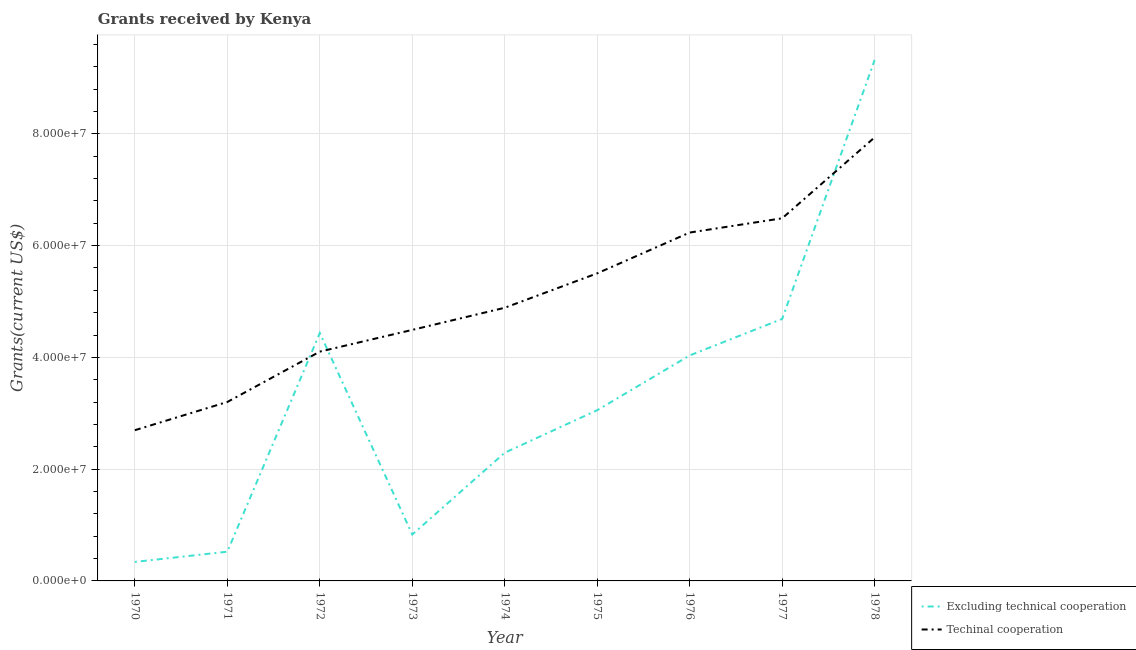Does the line corresponding to amount of grants received(including technical cooperation) intersect with the line corresponding to amount of grants received(excluding technical cooperation)?
Ensure brevity in your answer.  Yes. Is the number of lines equal to the number of legend labels?
Your answer should be compact. Yes. What is the amount of grants received(including technical cooperation) in 1973?
Your answer should be very brief. 4.49e+07. Across all years, what is the maximum amount of grants received(excluding technical cooperation)?
Your answer should be compact. 9.32e+07. Across all years, what is the minimum amount of grants received(including technical cooperation)?
Provide a succinct answer. 2.70e+07. In which year was the amount of grants received(excluding technical cooperation) maximum?
Keep it short and to the point. 1978. In which year was the amount of grants received(excluding technical cooperation) minimum?
Your answer should be compact. 1970. What is the total amount of grants received(excluding technical cooperation) in the graph?
Give a very brief answer. 2.95e+08. What is the difference between the amount of grants received(excluding technical cooperation) in 1974 and that in 1976?
Offer a terse response. -1.74e+07. What is the difference between the amount of grants received(including technical cooperation) in 1970 and the amount of grants received(excluding technical cooperation) in 1976?
Make the answer very short. -1.34e+07. What is the average amount of grants received(excluding technical cooperation) per year?
Your answer should be compact. 3.28e+07. In the year 1972, what is the difference between the amount of grants received(excluding technical cooperation) and amount of grants received(including technical cooperation)?
Your answer should be very brief. 3.33e+06. What is the ratio of the amount of grants received(excluding technical cooperation) in 1972 to that in 1976?
Your answer should be compact. 1.1. Is the difference between the amount of grants received(including technical cooperation) in 1971 and 1974 greater than the difference between the amount of grants received(excluding technical cooperation) in 1971 and 1974?
Your response must be concise. Yes. What is the difference between the highest and the second highest amount of grants received(excluding technical cooperation)?
Your response must be concise. 4.63e+07. What is the difference between the highest and the lowest amount of grants received(including technical cooperation)?
Provide a succinct answer. 5.24e+07. Does the amount of grants received(excluding technical cooperation) monotonically increase over the years?
Offer a terse response. No. Is the amount of grants received(excluding technical cooperation) strictly greater than the amount of grants received(including technical cooperation) over the years?
Your response must be concise. No. Is the amount of grants received(excluding technical cooperation) strictly less than the amount of grants received(including technical cooperation) over the years?
Provide a succinct answer. No. How many lines are there?
Make the answer very short. 2. How many years are there in the graph?
Keep it short and to the point. 9. Does the graph contain any zero values?
Your response must be concise. No. Where does the legend appear in the graph?
Your response must be concise. Bottom right. What is the title of the graph?
Provide a succinct answer. Grants received by Kenya. Does "Resident" appear as one of the legend labels in the graph?
Keep it short and to the point. No. What is the label or title of the X-axis?
Offer a terse response. Year. What is the label or title of the Y-axis?
Provide a succinct answer. Grants(current US$). What is the Grants(current US$) in Excluding technical cooperation in 1970?
Your answer should be compact. 3.40e+06. What is the Grants(current US$) in Techinal cooperation in 1970?
Your response must be concise. 2.70e+07. What is the Grants(current US$) of Excluding technical cooperation in 1971?
Your answer should be very brief. 5.23e+06. What is the Grants(current US$) in Techinal cooperation in 1971?
Your answer should be compact. 3.20e+07. What is the Grants(current US$) in Excluding technical cooperation in 1972?
Keep it short and to the point. 4.44e+07. What is the Grants(current US$) in Techinal cooperation in 1972?
Your answer should be compact. 4.10e+07. What is the Grants(current US$) in Excluding technical cooperation in 1973?
Make the answer very short. 8.30e+06. What is the Grants(current US$) of Techinal cooperation in 1973?
Provide a short and direct response. 4.49e+07. What is the Grants(current US$) in Excluding technical cooperation in 1974?
Provide a succinct answer. 2.29e+07. What is the Grants(current US$) in Techinal cooperation in 1974?
Provide a succinct answer. 4.89e+07. What is the Grants(current US$) in Excluding technical cooperation in 1975?
Give a very brief answer. 3.06e+07. What is the Grants(current US$) of Techinal cooperation in 1975?
Give a very brief answer. 5.50e+07. What is the Grants(current US$) of Excluding technical cooperation in 1976?
Your answer should be compact. 4.04e+07. What is the Grants(current US$) in Techinal cooperation in 1976?
Make the answer very short. 6.23e+07. What is the Grants(current US$) in Excluding technical cooperation in 1977?
Offer a terse response. 4.69e+07. What is the Grants(current US$) of Techinal cooperation in 1977?
Give a very brief answer. 6.49e+07. What is the Grants(current US$) in Excluding technical cooperation in 1978?
Provide a short and direct response. 9.32e+07. What is the Grants(current US$) in Techinal cooperation in 1978?
Your answer should be very brief. 7.94e+07. Across all years, what is the maximum Grants(current US$) of Excluding technical cooperation?
Your response must be concise. 9.32e+07. Across all years, what is the maximum Grants(current US$) in Techinal cooperation?
Offer a very short reply. 7.94e+07. Across all years, what is the minimum Grants(current US$) of Excluding technical cooperation?
Your answer should be compact. 3.40e+06. Across all years, what is the minimum Grants(current US$) of Techinal cooperation?
Your answer should be very brief. 2.70e+07. What is the total Grants(current US$) of Excluding technical cooperation in the graph?
Provide a succinct answer. 2.95e+08. What is the total Grants(current US$) in Techinal cooperation in the graph?
Offer a terse response. 4.55e+08. What is the difference between the Grants(current US$) in Excluding technical cooperation in 1970 and that in 1971?
Your answer should be compact. -1.83e+06. What is the difference between the Grants(current US$) of Techinal cooperation in 1970 and that in 1971?
Offer a very short reply. -5.05e+06. What is the difference between the Grants(current US$) in Excluding technical cooperation in 1970 and that in 1972?
Offer a terse response. -4.10e+07. What is the difference between the Grants(current US$) of Techinal cooperation in 1970 and that in 1972?
Offer a terse response. -1.41e+07. What is the difference between the Grants(current US$) in Excluding technical cooperation in 1970 and that in 1973?
Provide a succinct answer. -4.90e+06. What is the difference between the Grants(current US$) of Techinal cooperation in 1970 and that in 1973?
Provide a succinct answer. -1.80e+07. What is the difference between the Grants(current US$) in Excluding technical cooperation in 1970 and that in 1974?
Your answer should be compact. -1.95e+07. What is the difference between the Grants(current US$) in Techinal cooperation in 1970 and that in 1974?
Ensure brevity in your answer.  -2.19e+07. What is the difference between the Grants(current US$) in Excluding technical cooperation in 1970 and that in 1975?
Make the answer very short. -2.72e+07. What is the difference between the Grants(current US$) in Techinal cooperation in 1970 and that in 1975?
Provide a succinct answer. -2.81e+07. What is the difference between the Grants(current US$) in Excluding technical cooperation in 1970 and that in 1976?
Your answer should be very brief. -3.70e+07. What is the difference between the Grants(current US$) of Techinal cooperation in 1970 and that in 1976?
Provide a succinct answer. -3.54e+07. What is the difference between the Grants(current US$) of Excluding technical cooperation in 1970 and that in 1977?
Your response must be concise. -4.35e+07. What is the difference between the Grants(current US$) of Techinal cooperation in 1970 and that in 1977?
Your response must be concise. -3.79e+07. What is the difference between the Grants(current US$) of Excluding technical cooperation in 1970 and that in 1978?
Offer a terse response. -8.98e+07. What is the difference between the Grants(current US$) in Techinal cooperation in 1970 and that in 1978?
Make the answer very short. -5.24e+07. What is the difference between the Grants(current US$) of Excluding technical cooperation in 1971 and that in 1972?
Your response must be concise. -3.91e+07. What is the difference between the Grants(current US$) in Techinal cooperation in 1971 and that in 1972?
Keep it short and to the point. -9.01e+06. What is the difference between the Grants(current US$) in Excluding technical cooperation in 1971 and that in 1973?
Your answer should be very brief. -3.07e+06. What is the difference between the Grants(current US$) in Techinal cooperation in 1971 and that in 1973?
Ensure brevity in your answer.  -1.29e+07. What is the difference between the Grants(current US$) in Excluding technical cooperation in 1971 and that in 1974?
Keep it short and to the point. -1.77e+07. What is the difference between the Grants(current US$) of Techinal cooperation in 1971 and that in 1974?
Your answer should be very brief. -1.69e+07. What is the difference between the Grants(current US$) of Excluding technical cooperation in 1971 and that in 1975?
Keep it short and to the point. -2.53e+07. What is the difference between the Grants(current US$) of Techinal cooperation in 1971 and that in 1975?
Provide a short and direct response. -2.30e+07. What is the difference between the Grants(current US$) in Excluding technical cooperation in 1971 and that in 1976?
Ensure brevity in your answer.  -3.51e+07. What is the difference between the Grants(current US$) in Techinal cooperation in 1971 and that in 1976?
Offer a terse response. -3.03e+07. What is the difference between the Grants(current US$) of Excluding technical cooperation in 1971 and that in 1977?
Ensure brevity in your answer.  -4.16e+07. What is the difference between the Grants(current US$) of Techinal cooperation in 1971 and that in 1977?
Offer a terse response. -3.29e+07. What is the difference between the Grants(current US$) in Excluding technical cooperation in 1971 and that in 1978?
Provide a succinct answer. -8.80e+07. What is the difference between the Grants(current US$) in Techinal cooperation in 1971 and that in 1978?
Your response must be concise. -4.74e+07. What is the difference between the Grants(current US$) in Excluding technical cooperation in 1972 and that in 1973?
Offer a terse response. 3.61e+07. What is the difference between the Grants(current US$) in Techinal cooperation in 1972 and that in 1973?
Offer a terse response. -3.89e+06. What is the difference between the Grants(current US$) of Excluding technical cooperation in 1972 and that in 1974?
Your answer should be compact. 2.14e+07. What is the difference between the Grants(current US$) in Techinal cooperation in 1972 and that in 1974?
Offer a terse response. -7.85e+06. What is the difference between the Grants(current US$) of Excluding technical cooperation in 1972 and that in 1975?
Provide a succinct answer. 1.38e+07. What is the difference between the Grants(current US$) in Techinal cooperation in 1972 and that in 1975?
Keep it short and to the point. -1.40e+07. What is the difference between the Grants(current US$) of Excluding technical cooperation in 1972 and that in 1976?
Your response must be concise. 4.01e+06. What is the difference between the Grants(current US$) in Techinal cooperation in 1972 and that in 1976?
Provide a short and direct response. -2.13e+07. What is the difference between the Grants(current US$) of Excluding technical cooperation in 1972 and that in 1977?
Offer a terse response. -2.52e+06. What is the difference between the Grants(current US$) in Techinal cooperation in 1972 and that in 1977?
Provide a succinct answer. -2.39e+07. What is the difference between the Grants(current US$) in Excluding technical cooperation in 1972 and that in 1978?
Your answer should be compact. -4.89e+07. What is the difference between the Grants(current US$) in Techinal cooperation in 1972 and that in 1978?
Offer a very short reply. -3.83e+07. What is the difference between the Grants(current US$) of Excluding technical cooperation in 1973 and that in 1974?
Your response must be concise. -1.46e+07. What is the difference between the Grants(current US$) in Techinal cooperation in 1973 and that in 1974?
Ensure brevity in your answer.  -3.96e+06. What is the difference between the Grants(current US$) in Excluding technical cooperation in 1973 and that in 1975?
Provide a succinct answer. -2.22e+07. What is the difference between the Grants(current US$) of Techinal cooperation in 1973 and that in 1975?
Your answer should be very brief. -1.01e+07. What is the difference between the Grants(current US$) in Excluding technical cooperation in 1973 and that in 1976?
Provide a short and direct response. -3.20e+07. What is the difference between the Grants(current US$) of Techinal cooperation in 1973 and that in 1976?
Offer a very short reply. -1.74e+07. What is the difference between the Grants(current US$) in Excluding technical cooperation in 1973 and that in 1977?
Give a very brief answer. -3.86e+07. What is the difference between the Grants(current US$) in Techinal cooperation in 1973 and that in 1977?
Your answer should be compact. -2.00e+07. What is the difference between the Grants(current US$) of Excluding technical cooperation in 1973 and that in 1978?
Your answer should be very brief. -8.49e+07. What is the difference between the Grants(current US$) in Techinal cooperation in 1973 and that in 1978?
Provide a short and direct response. -3.44e+07. What is the difference between the Grants(current US$) of Excluding technical cooperation in 1974 and that in 1975?
Offer a terse response. -7.61e+06. What is the difference between the Grants(current US$) in Techinal cooperation in 1974 and that in 1975?
Your answer should be compact. -6.16e+06. What is the difference between the Grants(current US$) of Excluding technical cooperation in 1974 and that in 1976?
Your answer should be very brief. -1.74e+07. What is the difference between the Grants(current US$) of Techinal cooperation in 1974 and that in 1976?
Your answer should be very brief. -1.35e+07. What is the difference between the Grants(current US$) of Excluding technical cooperation in 1974 and that in 1977?
Your response must be concise. -2.39e+07. What is the difference between the Grants(current US$) in Techinal cooperation in 1974 and that in 1977?
Your answer should be compact. -1.60e+07. What is the difference between the Grants(current US$) of Excluding technical cooperation in 1974 and that in 1978?
Your response must be concise. -7.03e+07. What is the difference between the Grants(current US$) in Techinal cooperation in 1974 and that in 1978?
Your answer should be compact. -3.05e+07. What is the difference between the Grants(current US$) of Excluding technical cooperation in 1975 and that in 1976?
Your answer should be very brief. -9.80e+06. What is the difference between the Grants(current US$) of Techinal cooperation in 1975 and that in 1976?
Make the answer very short. -7.30e+06. What is the difference between the Grants(current US$) in Excluding technical cooperation in 1975 and that in 1977?
Provide a short and direct response. -1.63e+07. What is the difference between the Grants(current US$) in Techinal cooperation in 1975 and that in 1977?
Ensure brevity in your answer.  -9.85e+06. What is the difference between the Grants(current US$) in Excluding technical cooperation in 1975 and that in 1978?
Ensure brevity in your answer.  -6.27e+07. What is the difference between the Grants(current US$) of Techinal cooperation in 1975 and that in 1978?
Your response must be concise. -2.43e+07. What is the difference between the Grants(current US$) in Excluding technical cooperation in 1976 and that in 1977?
Your answer should be compact. -6.53e+06. What is the difference between the Grants(current US$) in Techinal cooperation in 1976 and that in 1977?
Your response must be concise. -2.55e+06. What is the difference between the Grants(current US$) in Excluding technical cooperation in 1976 and that in 1978?
Provide a short and direct response. -5.29e+07. What is the difference between the Grants(current US$) in Techinal cooperation in 1976 and that in 1978?
Ensure brevity in your answer.  -1.70e+07. What is the difference between the Grants(current US$) in Excluding technical cooperation in 1977 and that in 1978?
Offer a terse response. -4.63e+07. What is the difference between the Grants(current US$) of Techinal cooperation in 1977 and that in 1978?
Keep it short and to the point. -1.45e+07. What is the difference between the Grants(current US$) in Excluding technical cooperation in 1970 and the Grants(current US$) in Techinal cooperation in 1971?
Your answer should be compact. -2.86e+07. What is the difference between the Grants(current US$) in Excluding technical cooperation in 1970 and the Grants(current US$) in Techinal cooperation in 1972?
Your answer should be compact. -3.76e+07. What is the difference between the Grants(current US$) of Excluding technical cooperation in 1970 and the Grants(current US$) of Techinal cooperation in 1973?
Make the answer very short. -4.15e+07. What is the difference between the Grants(current US$) of Excluding technical cooperation in 1970 and the Grants(current US$) of Techinal cooperation in 1974?
Keep it short and to the point. -4.55e+07. What is the difference between the Grants(current US$) in Excluding technical cooperation in 1970 and the Grants(current US$) in Techinal cooperation in 1975?
Ensure brevity in your answer.  -5.16e+07. What is the difference between the Grants(current US$) of Excluding technical cooperation in 1970 and the Grants(current US$) of Techinal cooperation in 1976?
Offer a very short reply. -5.89e+07. What is the difference between the Grants(current US$) in Excluding technical cooperation in 1970 and the Grants(current US$) in Techinal cooperation in 1977?
Provide a succinct answer. -6.15e+07. What is the difference between the Grants(current US$) in Excluding technical cooperation in 1970 and the Grants(current US$) in Techinal cooperation in 1978?
Your response must be concise. -7.60e+07. What is the difference between the Grants(current US$) of Excluding technical cooperation in 1971 and the Grants(current US$) of Techinal cooperation in 1972?
Your answer should be compact. -3.58e+07. What is the difference between the Grants(current US$) in Excluding technical cooperation in 1971 and the Grants(current US$) in Techinal cooperation in 1973?
Offer a very short reply. -3.97e+07. What is the difference between the Grants(current US$) of Excluding technical cooperation in 1971 and the Grants(current US$) of Techinal cooperation in 1974?
Your response must be concise. -4.36e+07. What is the difference between the Grants(current US$) in Excluding technical cooperation in 1971 and the Grants(current US$) in Techinal cooperation in 1975?
Make the answer very short. -4.98e+07. What is the difference between the Grants(current US$) in Excluding technical cooperation in 1971 and the Grants(current US$) in Techinal cooperation in 1976?
Your answer should be very brief. -5.71e+07. What is the difference between the Grants(current US$) of Excluding technical cooperation in 1971 and the Grants(current US$) of Techinal cooperation in 1977?
Make the answer very short. -5.97e+07. What is the difference between the Grants(current US$) of Excluding technical cooperation in 1971 and the Grants(current US$) of Techinal cooperation in 1978?
Offer a very short reply. -7.41e+07. What is the difference between the Grants(current US$) in Excluding technical cooperation in 1972 and the Grants(current US$) in Techinal cooperation in 1973?
Offer a terse response. -5.60e+05. What is the difference between the Grants(current US$) in Excluding technical cooperation in 1972 and the Grants(current US$) in Techinal cooperation in 1974?
Provide a succinct answer. -4.52e+06. What is the difference between the Grants(current US$) in Excluding technical cooperation in 1972 and the Grants(current US$) in Techinal cooperation in 1975?
Provide a succinct answer. -1.07e+07. What is the difference between the Grants(current US$) in Excluding technical cooperation in 1972 and the Grants(current US$) in Techinal cooperation in 1976?
Offer a terse response. -1.80e+07. What is the difference between the Grants(current US$) in Excluding technical cooperation in 1972 and the Grants(current US$) in Techinal cooperation in 1977?
Ensure brevity in your answer.  -2.05e+07. What is the difference between the Grants(current US$) of Excluding technical cooperation in 1972 and the Grants(current US$) of Techinal cooperation in 1978?
Provide a short and direct response. -3.50e+07. What is the difference between the Grants(current US$) in Excluding technical cooperation in 1973 and the Grants(current US$) in Techinal cooperation in 1974?
Provide a succinct answer. -4.06e+07. What is the difference between the Grants(current US$) of Excluding technical cooperation in 1973 and the Grants(current US$) of Techinal cooperation in 1975?
Offer a terse response. -4.67e+07. What is the difference between the Grants(current US$) of Excluding technical cooperation in 1973 and the Grants(current US$) of Techinal cooperation in 1976?
Provide a succinct answer. -5.40e+07. What is the difference between the Grants(current US$) in Excluding technical cooperation in 1973 and the Grants(current US$) in Techinal cooperation in 1977?
Your answer should be compact. -5.66e+07. What is the difference between the Grants(current US$) in Excluding technical cooperation in 1973 and the Grants(current US$) in Techinal cooperation in 1978?
Offer a terse response. -7.11e+07. What is the difference between the Grants(current US$) of Excluding technical cooperation in 1974 and the Grants(current US$) of Techinal cooperation in 1975?
Offer a very short reply. -3.21e+07. What is the difference between the Grants(current US$) of Excluding technical cooperation in 1974 and the Grants(current US$) of Techinal cooperation in 1976?
Your answer should be compact. -3.94e+07. What is the difference between the Grants(current US$) in Excluding technical cooperation in 1974 and the Grants(current US$) in Techinal cooperation in 1977?
Give a very brief answer. -4.20e+07. What is the difference between the Grants(current US$) in Excluding technical cooperation in 1974 and the Grants(current US$) in Techinal cooperation in 1978?
Give a very brief answer. -5.64e+07. What is the difference between the Grants(current US$) of Excluding technical cooperation in 1975 and the Grants(current US$) of Techinal cooperation in 1976?
Offer a very short reply. -3.18e+07. What is the difference between the Grants(current US$) of Excluding technical cooperation in 1975 and the Grants(current US$) of Techinal cooperation in 1977?
Provide a short and direct response. -3.43e+07. What is the difference between the Grants(current US$) in Excluding technical cooperation in 1975 and the Grants(current US$) in Techinal cooperation in 1978?
Make the answer very short. -4.88e+07. What is the difference between the Grants(current US$) of Excluding technical cooperation in 1976 and the Grants(current US$) of Techinal cooperation in 1977?
Offer a very short reply. -2.45e+07. What is the difference between the Grants(current US$) of Excluding technical cooperation in 1976 and the Grants(current US$) of Techinal cooperation in 1978?
Offer a terse response. -3.90e+07. What is the difference between the Grants(current US$) of Excluding technical cooperation in 1977 and the Grants(current US$) of Techinal cooperation in 1978?
Make the answer very short. -3.25e+07. What is the average Grants(current US$) of Excluding technical cooperation per year?
Make the answer very short. 3.28e+07. What is the average Grants(current US$) in Techinal cooperation per year?
Your answer should be very brief. 5.06e+07. In the year 1970, what is the difference between the Grants(current US$) of Excluding technical cooperation and Grants(current US$) of Techinal cooperation?
Provide a succinct answer. -2.36e+07. In the year 1971, what is the difference between the Grants(current US$) in Excluding technical cooperation and Grants(current US$) in Techinal cooperation?
Ensure brevity in your answer.  -2.68e+07. In the year 1972, what is the difference between the Grants(current US$) of Excluding technical cooperation and Grants(current US$) of Techinal cooperation?
Your answer should be very brief. 3.33e+06. In the year 1973, what is the difference between the Grants(current US$) of Excluding technical cooperation and Grants(current US$) of Techinal cooperation?
Offer a terse response. -3.66e+07. In the year 1974, what is the difference between the Grants(current US$) in Excluding technical cooperation and Grants(current US$) in Techinal cooperation?
Your answer should be very brief. -2.59e+07. In the year 1975, what is the difference between the Grants(current US$) of Excluding technical cooperation and Grants(current US$) of Techinal cooperation?
Your answer should be very brief. -2.45e+07. In the year 1976, what is the difference between the Grants(current US$) of Excluding technical cooperation and Grants(current US$) of Techinal cooperation?
Provide a succinct answer. -2.20e+07. In the year 1977, what is the difference between the Grants(current US$) in Excluding technical cooperation and Grants(current US$) in Techinal cooperation?
Keep it short and to the point. -1.80e+07. In the year 1978, what is the difference between the Grants(current US$) in Excluding technical cooperation and Grants(current US$) in Techinal cooperation?
Keep it short and to the point. 1.38e+07. What is the ratio of the Grants(current US$) in Excluding technical cooperation in 1970 to that in 1971?
Offer a very short reply. 0.65. What is the ratio of the Grants(current US$) in Techinal cooperation in 1970 to that in 1971?
Your response must be concise. 0.84. What is the ratio of the Grants(current US$) of Excluding technical cooperation in 1970 to that in 1972?
Provide a succinct answer. 0.08. What is the ratio of the Grants(current US$) of Techinal cooperation in 1970 to that in 1972?
Make the answer very short. 0.66. What is the ratio of the Grants(current US$) of Excluding technical cooperation in 1970 to that in 1973?
Your answer should be very brief. 0.41. What is the ratio of the Grants(current US$) in Techinal cooperation in 1970 to that in 1973?
Provide a succinct answer. 0.6. What is the ratio of the Grants(current US$) of Excluding technical cooperation in 1970 to that in 1974?
Provide a short and direct response. 0.15. What is the ratio of the Grants(current US$) in Techinal cooperation in 1970 to that in 1974?
Provide a succinct answer. 0.55. What is the ratio of the Grants(current US$) in Excluding technical cooperation in 1970 to that in 1975?
Offer a very short reply. 0.11. What is the ratio of the Grants(current US$) of Techinal cooperation in 1970 to that in 1975?
Your answer should be very brief. 0.49. What is the ratio of the Grants(current US$) of Excluding technical cooperation in 1970 to that in 1976?
Keep it short and to the point. 0.08. What is the ratio of the Grants(current US$) in Techinal cooperation in 1970 to that in 1976?
Your answer should be compact. 0.43. What is the ratio of the Grants(current US$) of Excluding technical cooperation in 1970 to that in 1977?
Keep it short and to the point. 0.07. What is the ratio of the Grants(current US$) of Techinal cooperation in 1970 to that in 1977?
Offer a terse response. 0.42. What is the ratio of the Grants(current US$) in Excluding technical cooperation in 1970 to that in 1978?
Keep it short and to the point. 0.04. What is the ratio of the Grants(current US$) in Techinal cooperation in 1970 to that in 1978?
Your answer should be very brief. 0.34. What is the ratio of the Grants(current US$) of Excluding technical cooperation in 1971 to that in 1972?
Your answer should be very brief. 0.12. What is the ratio of the Grants(current US$) of Techinal cooperation in 1971 to that in 1972?
Offer a terse response. 0.78. What is the ratio of the Grants(current US$) of Excluding technical cooperation in 1971 to that in 1973?
Offer a terse response. 0.63. What is the ratio of the Grants(current US$) of Techinal cooperation in 1971 to that in 1973?
Give a very brief answer. 0.71. What is the ratio of the Grants(current US$) in Excluding technical cooperation in 1971 to that in 1974?
Provide a short and direct response. 0.23. What is the ratio of the Grants(current US$) of Techinal cooperation in 1971 to that in 1974?
Provide a short and direct response. 0.66. What is the ratio of the Grants(current US$) in Excluding technical cooperation in 1971 to that in 1975?
Make the answer very short. 0.17. What is the ratio of the Grants(current US$) of Techinal cooperation in 1971 to that in 1975?
Give a very brief answer. 0.58. What is the ratio of the Grants(current US$) in Excluding technical cooperation in 1971 to that in 1976?
Make the answer very short. 0.13. What is the ratio of the Grants(current US$) in Techinal cooperation in 1971 to that in 1976?
Provide a succinct answer. 0.51. What is the ratio of the Grants(current US$) in Excluding technical cooperation in 1971 to that in 1977?
Provide a succinct answer. 0.11. What is the ratio of the Grants(current US$) in Techinal cooperation in 1971 to that in 1977?
Make the answer very short. 0.49. What is the ratio of the Grants(current US$) in Excluding technical cooperation in 1971 to that in 1978?
Give a very brief answer. 0.06. What is the ratio of the Grants(current US$) of Techinal cooperation in 1971 to that in 1978?
Provide a succinct answer. 0.4. What is the ratio of the Grants(current US$) of Excluding technical cooperation in 1972 to that in 1973?
Give a very brief answer. 5.34. What is the ratio of the Grants(current US$) of Techinal cooperation in 1972 to that in 1973?
Make the answer very short. 0.91. What is the ratio of the Grants(current US$) of Excluding technical cooperation in 1972 to that in 1974?
Your answer should be very brief. 1.93. What is the ratio of the Grants(current US$) in Techinal cooperation in 1972 to that in 1974?
Offer a very short reply. 0.84. What is the ratio of the Grants(current US$) of Excluding technical cooperation in 1972 to that in 1975?
Offer a terse response. 1.45. What is the ratio of the Grants(current US$) in Techinal cooperation in 1972 to that in 1975?
Your answer should be very brief. 0.75. What is the ratio of the Grants(current US$) in Excluding technical cooperation in 1972 to that in 1976?
Your answer should be very brief. 1.1. What is the ratio of the Grants(current US$) of Techinal cooperation in 1972 to that in 1976?
Your response must be concise. 0.66. What is the ratio of the Grants(current US$) in Excluding technical cooperation in 1972 to that in 1977?
Offer a terse response. 0.95. What is the ratio of the Grants(current US$) of Techinal cooperation in 1972 to that in 1977?
Provide a short and direct response. 0.63. What is the ratio of the Grants(current US$) in Excluding technical cooperation in 1972 to that in 1978?
Your answer should be compact. 0.48. What is the ratio of the Grants(current US$) in Techinal cooperation in 1972 to that in 1978?
Keep it short and to the point. 0.52. What is the ratio of the Grants(current US$) in Excluding technical cooperation in 1973 to that in 1974?
Provide a short and direct response. 0.36. What is the ratio of the Grants(current US$) of Techinal cooperation in 1973 to that in 1974?
Offer a terse response. 0.92. What is the ratio of the Grants(current US$) of Excluding technical cooperation in 1973 to that in 1975?
Keep it short and to the point. 0.27. What is the ratio of the Grants(current US$) of Techinal cooperation in 1973 to that in 1975?
Your answer should be very brief. 0.82. What is the ratio of the Grants(current US$) of Excluding technical cooperation in 1973 to that in 1976?
Your answer should be compact. 0.21. What is the ratio of the Grants(current US$) of Techinal cooperation in 1973 to that in 1976?
Make the answer very short. 0.72. What is the ratio of the Grants(current US$) in Excluding technical cooperation in 1973 to that in 1977?
Offer a very short reply. 0.18. What is the ratio of the Grants(current US$) in Techinal cooperation in 1973 to that in 1977?
Give a very brief answer. 0.69. What is the ratio of the Grants(current US$) in Excluding technical cooperation in 1973 to that in 1978?
Give a very brief answer. 0.09. What is the ratio of the Grants(current US$) of Techinal cooperation in 1973 to that in 1978?
Your answer should be very brief. 0.57. What is the ratio of the Grants(current US$) of Excluding technical cooperation in 1974 to that in 1975?
Your answer should be very brief. 0.75. What is the ratio of the Grants(current US$) in Techinal cooperation in 1974 to that in 1975?
Your response must be concise. 0.89. What is the ratio of the Grants(current US$) of Excluding technical cooperation in 1974 to that in 1976?
Your response must be concise. 0.57. What is the ratio of the Grants(current US$) in Techinal cooperation in 1974 to that in 1976?
Offer a terse response. 0.78. What is the ratio of the Grants(current US$) in Excluding technical cooperation in 1974 to that in 1977?
Your answer should be very brief. 0.49. What is the ratio of the Grants(current US$) in Techinal cooperation in 1974 to that in 1977?
Your response must be concise. 0.75. What is the ratio of the Grants(current US$) of Excluding technical cooperation in 1974 to that in 1978?
Your answer should be compact. 0.25. What is the ratio of the Grants(current US$) of Techinal cooperation in 1974 to that in 1978?
Your response must be concise. 0.62. What is the ratio of the Grants(current US$) of Excluding technical cooperation in 1975 to that in 1976?
Keep it short and to the point. 0.76. What is the ratio of the Grants(current US$) in Techinal cooperation in 1975 to that in 1976?
Your answer should be very brief. 0.88. What is the ratio of the Grants(current US$) of Excluding technical cooperation in 1975 to that in 1977?
Provide a succinct answer. 0.65. What is the ratio of the Grants(current US$) of Techinal cooperation in 1975 to that in 1977?
Offer a terse response. 0.85. What is the ratio of the Grants(current US$) in Excluding technical cooperation in 1975 to that in 1978?
Provide a short and direct response. 0.33. What is the ratio of the Grants(current US$) of Techinal cooperation in 1975 to that in 1978?
Provide a short and direct response. 0.69. What is the ratio of the Grants(current US$) in Excluding technical cooperation in 1976 to that in 1977?
Your answer should be very brief. 0.86. What is the ratio of the Grants(current US$) of Techinal cooperation in 1976 to that in 1977?
Your answer should be very brief. 0.96. What is the ratio of the Grants(current US$) of Excluding technical cooperation in 1976 to that in 1978?
Your answer should be compact. 0.43. What is the ratio of the Grants(current US$) of Techinal cooperation in 1976 to that in 1978?
Make the answer very short. 0.79. What is the ratio of the Grants(current US$) of Excluding technical cooperation in 1977 to that in 1978?
Provide a short and direct response. 0.5. What is the ratio of the Grants(current US$) of Techinal cooperation in 1977 to that in 1978?
Make the answer very short. 0.82. What is the difference between the highest and the second highest Grants(current US$) of Excluding technical cooperation?
Keep it short and to the point. 4.63e+07. What is the difference between the highest and the second highest Grants(current US$) in Techinal cooperation?
Provide a succinct answer. 1.45e+07. What is the difference between the highest and the lowest Grants(current US$) in Excluding technical cooperation?
Offer a terse response. 8.98e+07. What is the difference between the highest and the lowest Grants(current US$) in Techinal cooperation?
Provide a short and direct response. 5.24e+07. 